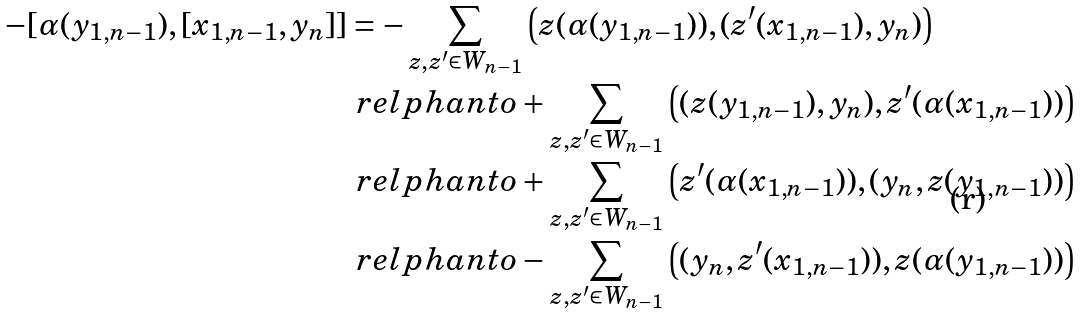<formula> <loc_0><loc_0><loc_500><loc_500>- [ \alpha ( y _ { 1 , n - 1 } ) , [ x _ { 1 , n - 1 } , y _ { n } ] ] & = - \sum _ { z , z ^ { \prime } \in W _ { n - 1 } } \left ( z ( \alpha ( y _ { 1 , n - 1 } ) ) , ( z ^ { \prime } ( x _ { 1 , n - 1 } ) , y _ { n } ) \right ) \\ & \ r e l p h a n t o + \sum _ { z , z ^ { \prime } \in W _ { n - 1 } } \left ( ( z ( y _ { 1 , n - 1 } ) , y _ { n } ) , z ^ { \prime } ( \alpha ( x _ { 1 , n - 1 } ) ) \right ) \\ & \ r e l p h a n t o + \sum _ { z , z ^ { \prime } \in W _ { n - 1 } } \left ( z ^ { \prime } ( \alpha ( x _ { 1 , n - 1 } ) ) , ( y _ { n } , z ( y _ { 1 , n - 1 } ) ) \right ) \\ & \ r e l p h a n t o - \sum _ { z , z ^ { \prime } \in W _ { n - 1 } } \left ( ( y _ { n } , z ^ { \prime } ( x _ { 1 , n - 1 } ) ) , z ( \alpha ( y _ { 1 , n - 1 } ) ) \right )</formula> 